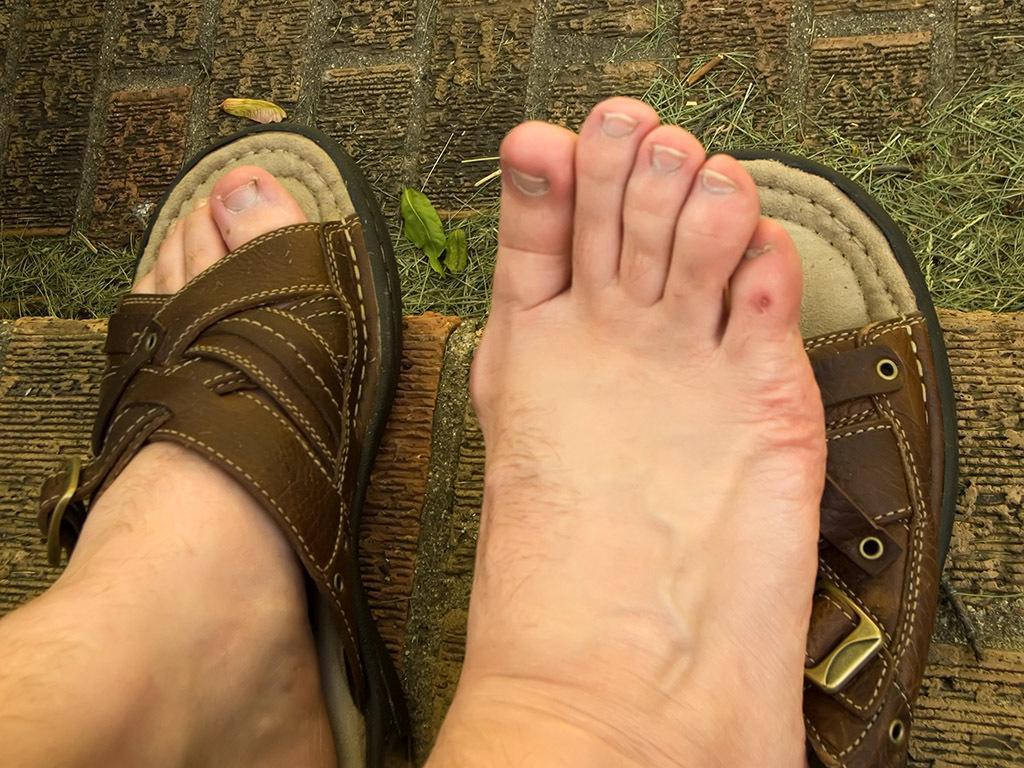Describe this image in one or two sentences. In this image I can see the person´s legs and I can also see the footwear of the person. In the background I can see the grass in green color. 